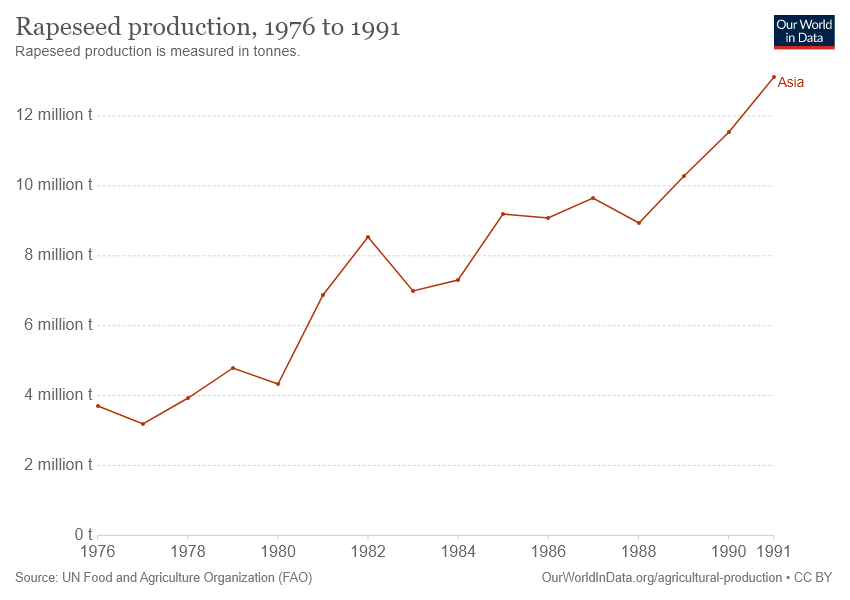Highlight a few significant elements in this photo. The graph displays the region that is Asia. Rapeseed production reached its lowest level in 1977. 